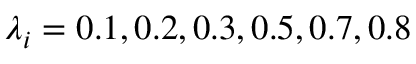Convert formula to latex. <formula><loc_0><loc_0><loc_500><loc_500>\lambda _ { i } = 0 . 1 , 0 . 2 , 0 . 3 , 0 . 5 , 0 . 7 , 0 . 8</formula> 